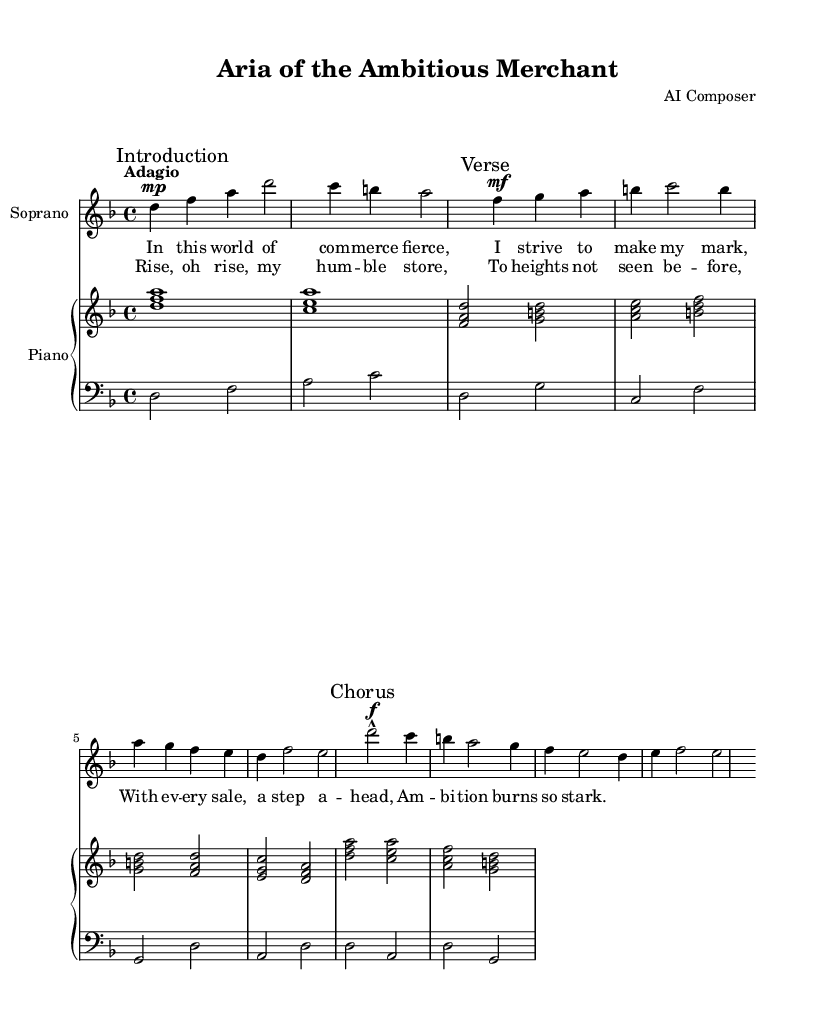What is the key signature of this music? The key signature is indicated at the beginning of the staff with one flat, which is characteristic of D minor.
Answer: D minor What is the time signature of this piece? The time signature is shown at the beginning of the score, which indicates the number of beats per measure, here represented as 4 over 4.
Answer: 4/4 What is the tempo marking in this piece? The tempo is written above the staff, describing the speed of the piece as "Adagio," which indicates a slow tempo.
Answer: Adagio How many measures are in the soprano part? By counting the measures in the soprano line, we find that there are a total of 7 measures present, including the introduction and the subsequent verses and chorus.
Answer: 7 What type of structure does this opera piece exhibit? The score has a clear structure, consisting of an introduction, verse, and a chorus, which are typical elements found in opera compositions.
Answer: Introduction, Verse, Chorus What does the term "marcato" indicate in this piece? "Marcato" is an articulation marking that suggests the notes should be played with emphasis or a strong accent, which affects the performance interpretation.
Answer: Emphasis How does the music express the theme of ambition? The lyrics convey a message of striving and determination, as well as the rising aspirations of a merchant, which are emotionally supported by the musical dynamics and tempo.
Answer: Striving and determination 